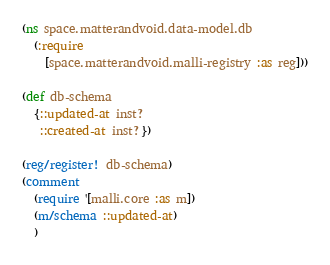Convert code to text. <code><loc_0><loc_0><loc_500><loc_500><_Clojure_>(ns space.matterandvoid.data-model.db
  (:require
    [space.matterandvoid.malli-registry :as reg]))

(def db-schema
  {::updated-at inst?
   ::created-at inst?})

(reg/register! db-schema)
(comment
  (require '[malli.core :as m])
  (m/schema ::updated-at)
  )
</code> 